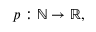<formula> <loc_0><loc_0><loc_500><loc_500>p \colon \mathbb { N } \rightarrow \mathbb { R } ,</formula> 